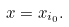Convert formula to latex. <formula><loc_0><loc_0><loc_500><loc_500>x = x _ { i _ { 0 } } .</formula> 